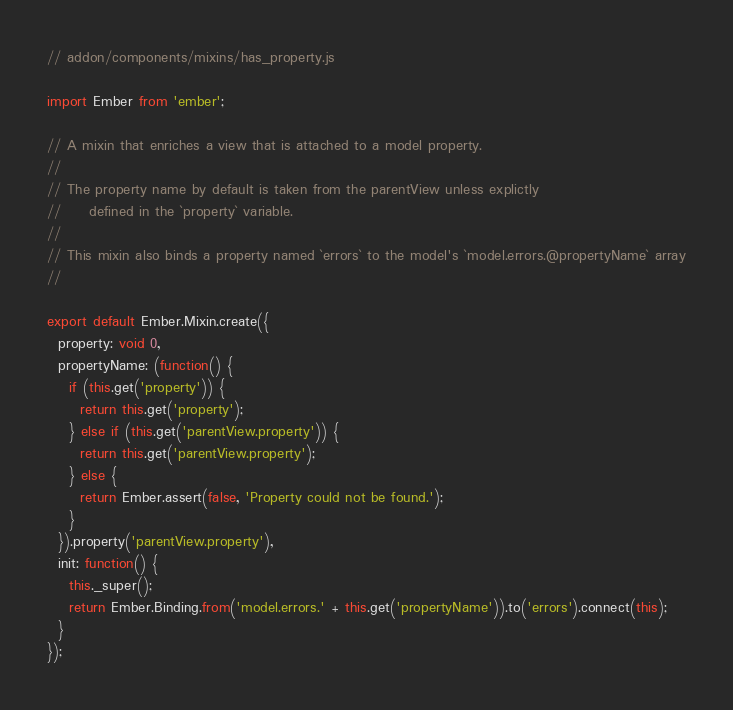<code> <loc_0><loc_0><loc_500><loc_500><_JavaScript_>// addon/components/mixins/has_property.js

import Ember from 'ember';

// A mixin that enriches a view that is attached to a model property.
//
// The property name by default is taken from the parentView unless explictly
//     defined in the `property` variable.
//
// This mixin also binds a property named `errors` to the model's `model.errors.@propertyName` array
// 

export default Ember.Mixin.create({
  property: void 0,
  propertyName: (function() {
    if (this.get('property')) {
      return this.get('property');
    } else if (this.get('parentView.property')) {
      return this.get('parentView.property');
    } else {
      return Ember.assert(false, 'Property could not be found.');
    }
  }).property('parentView.property'),
  init: function() {
    this._super();
    return Ember.Binding.from('model.errors.' + this.get('propertyName')).to('errors').connect(this);
  }
});</code> 